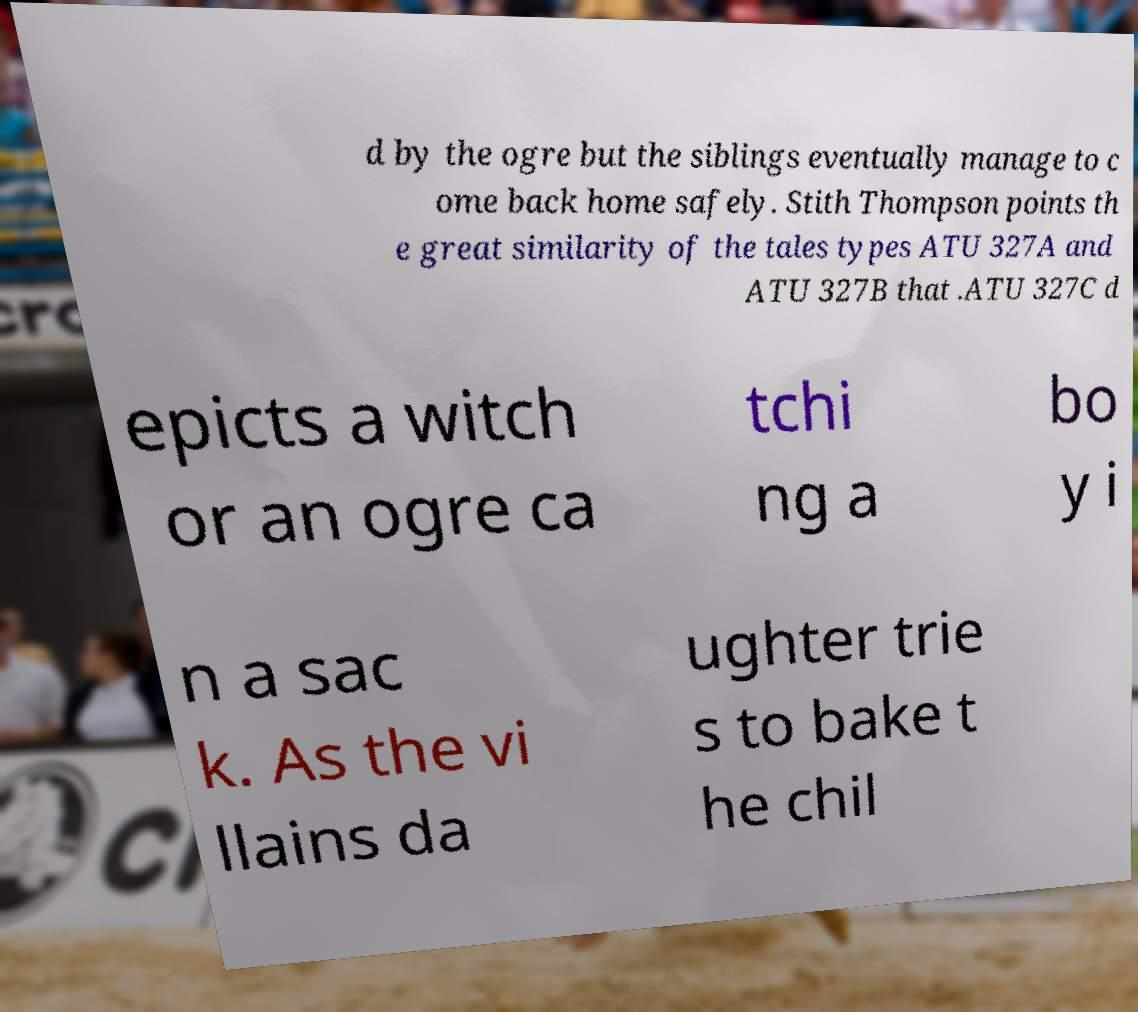Can you accurately transcribe the text from the provided image for me? d by the ogre but the siblings eventually manage to c ome back home safely. Stith Thompson points th e great similarity of the tales types ATU 327A and ATU 327B that .ATU 327C d epicts a witch or an ogre ca tchi ng a bo y i n a sac k. As the vi llains da ughter trie s to bake t he chil 